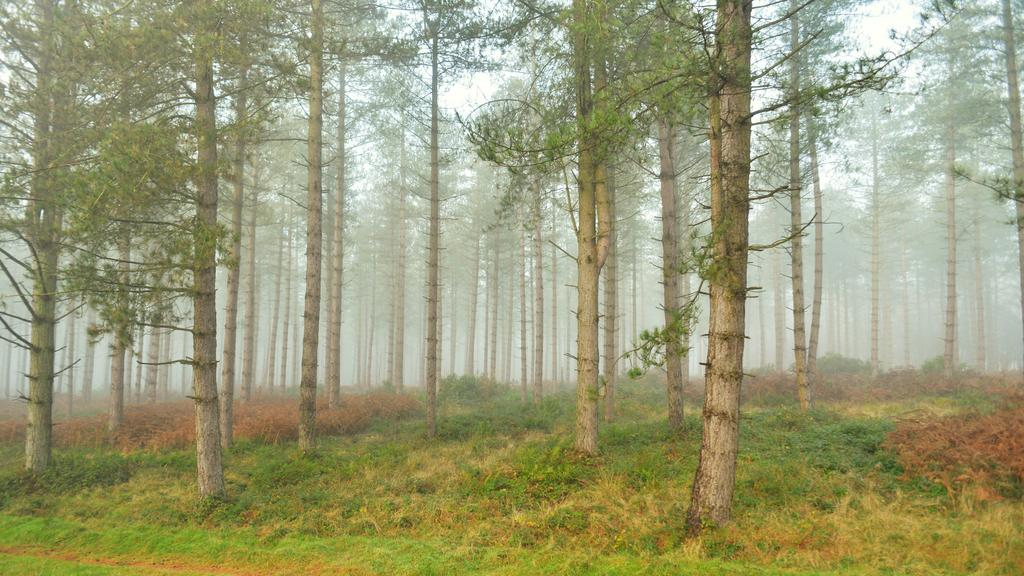What type of vegetation is present in the image? There are many trees in the image. What covers the ground in the image? There is grass on the ground in the image. What can be seen in the background of the image? The sky is visible in the background of the image. What type of rod can be seen on the roof of the building in the image? There is no building or rod present in the image; it features trees and grass. What type of tank is visible in the image? There is no tank present in the image; it features trees and grass. 